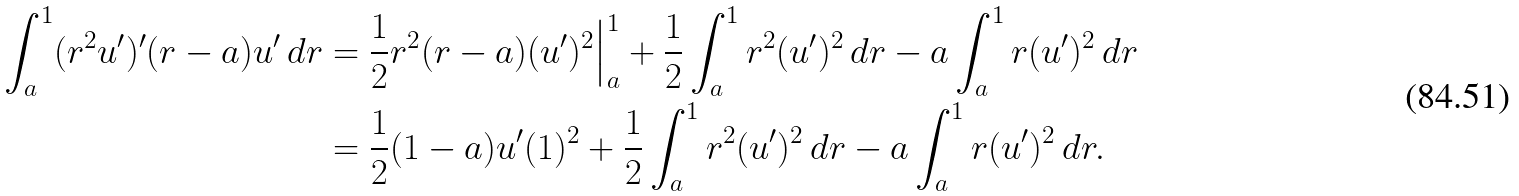<formula> <loc_0><loc_0><loc_500><loc_500>\int _ { a } ^ { 1 } ( r ^ { 2 } u ^ { \prime } ) ^ { \prime } ( r - a ) u ^ { \prime } \, d r & = \frac { 1 } { 2 } r ^ { 2 } ( r - a ) ( u ^ { \prime } ) ^ { 2 } \Big | _ { a } ^ { 1 } + \frac { 1 } { 2 } \int _ { a } ^ { 1 } r ^ { 2 } ( u ^ { \prime } ) ^ { 2 } \, d r - a \int _ { a } ^ { 1 } r ( u ^ { \prime } ) ^ { 2 } \, d r \\ & = \frac { 1 } { 2 } ( 1 - a ) u ^ { \prime } ( 1 ) ^ { 2 } + \frac { 1 } { 2 } \int _ { a } ^ { 1 } r ^ { 2 } ( u ^ { \prime } ) ^ { 2 } \, d r - a \int _ { a } ^ { 1 } r ( u ^ { \prime } ) ^ { 2 } \, d r .</formula> 